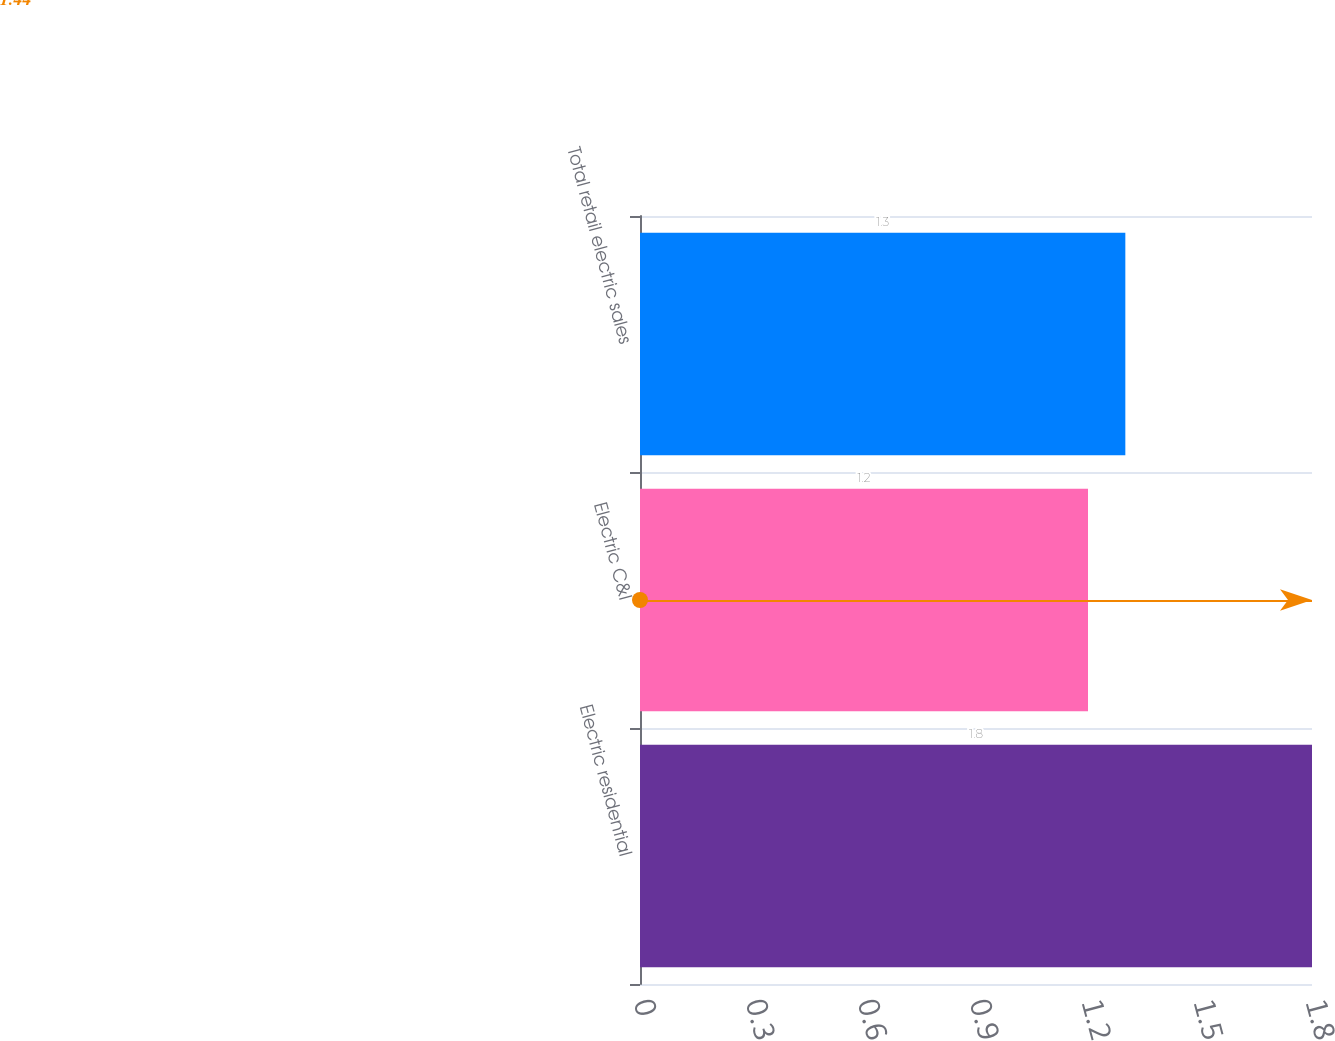Convert chart to OTSL. <chart><loc_0><loc_0><loc_500><loc_500><bar_chart><fcel>Electric residential<fcel>Electric C&I<fcel>Total retail electric sales<nl><fcel>1.8<fcel>1.2<fcel>1.3<nl></chart> 